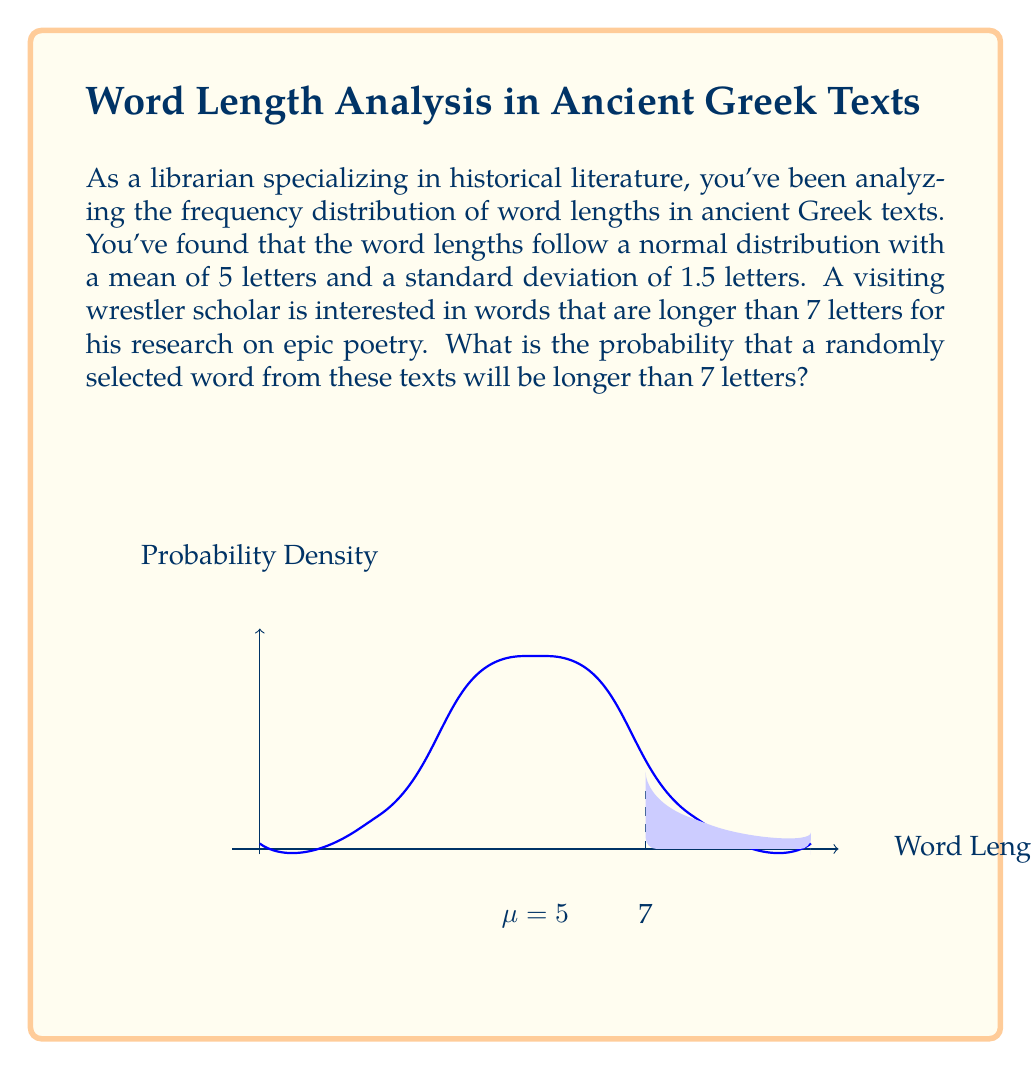Provide a solution to this math problem. To solve this problem, we'll use the properties of the normal distribution and the concept of z-scores.

Step 1: Identify the given information
- Mean (μ) = 5 letters
- Standard deviation (σ) = 1.5 letters
- We want to find P(X > 7), where X is the word length

Step 2: Calculate the z-score for 7 letters
The z-score formula is: $z = \frac{x - \mu}{\sigma}$

$z = \frac{7 - 5}{1.5} = \frac{2}{1.5} \approx 1.33$

Step 3: Find the probability using the standard normal distribution
We need to find P(Z > 1.33)

Using a standard normal table or calculator:
P(Z > 1.33) = 1 - P(Z < 1.33) = 1 - 0.9082 ≈ 0.0918

Step 4: Interpret the result
The probability that a randomly selected word will be longer than 7 letters is approximately 0.0918 or 9.18%
Answer: 0.0918 or 9.18% 